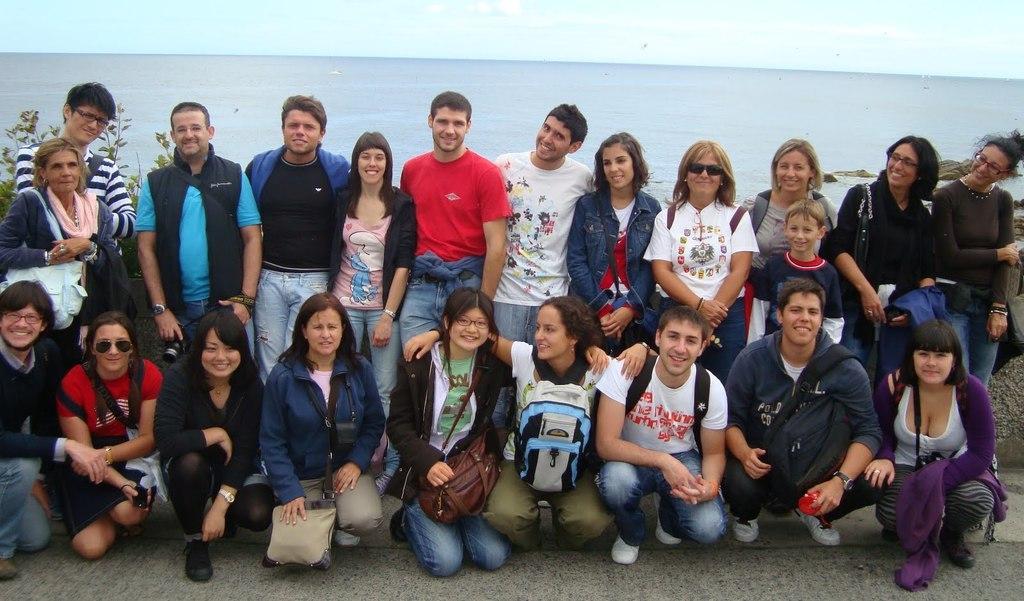In one or two sentences, can you explain what this image depicts? In this image we can see some group of persons some are standing and some are crouching down wearing backpacks, carrying bags posing for a photograph and in the background of the image there is water, clear sky, some plants. 